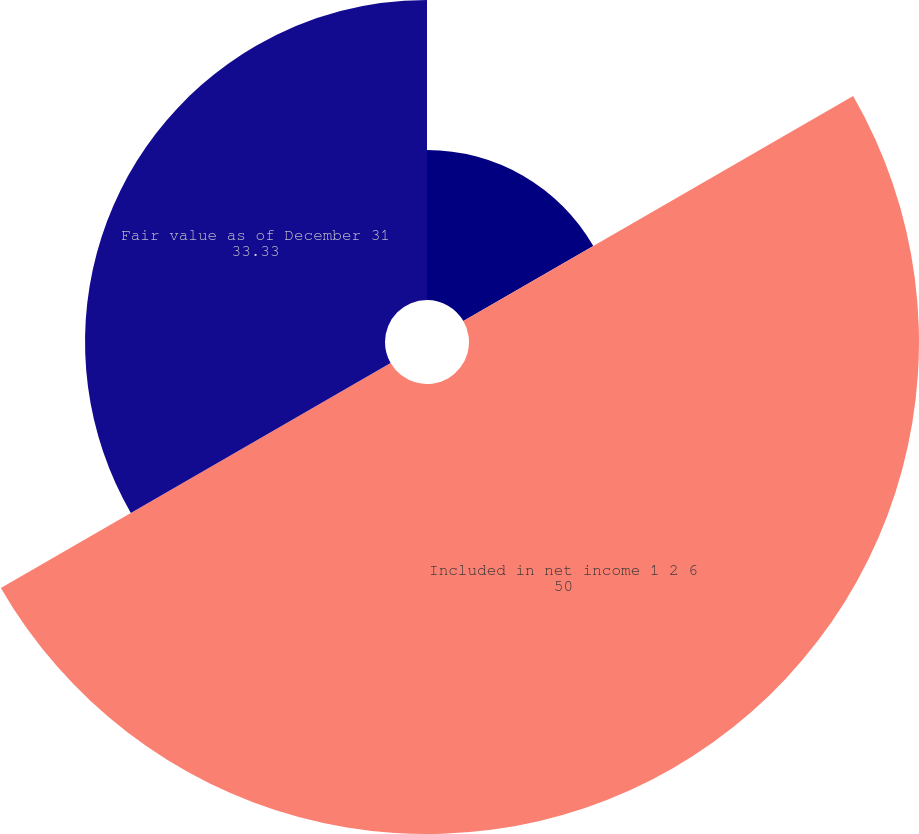Convert chart to OTSL. <chart><loc_0><loc_0><loc_500><loc_500><pie_chart><fcel>Fair value as of January 1<fcel>Included in net income 1 2 6<fcel>Fair value as of December 31<nl><fcel>16.67%<fcel>50.0%<fcel>33.33%<nl></chart> 